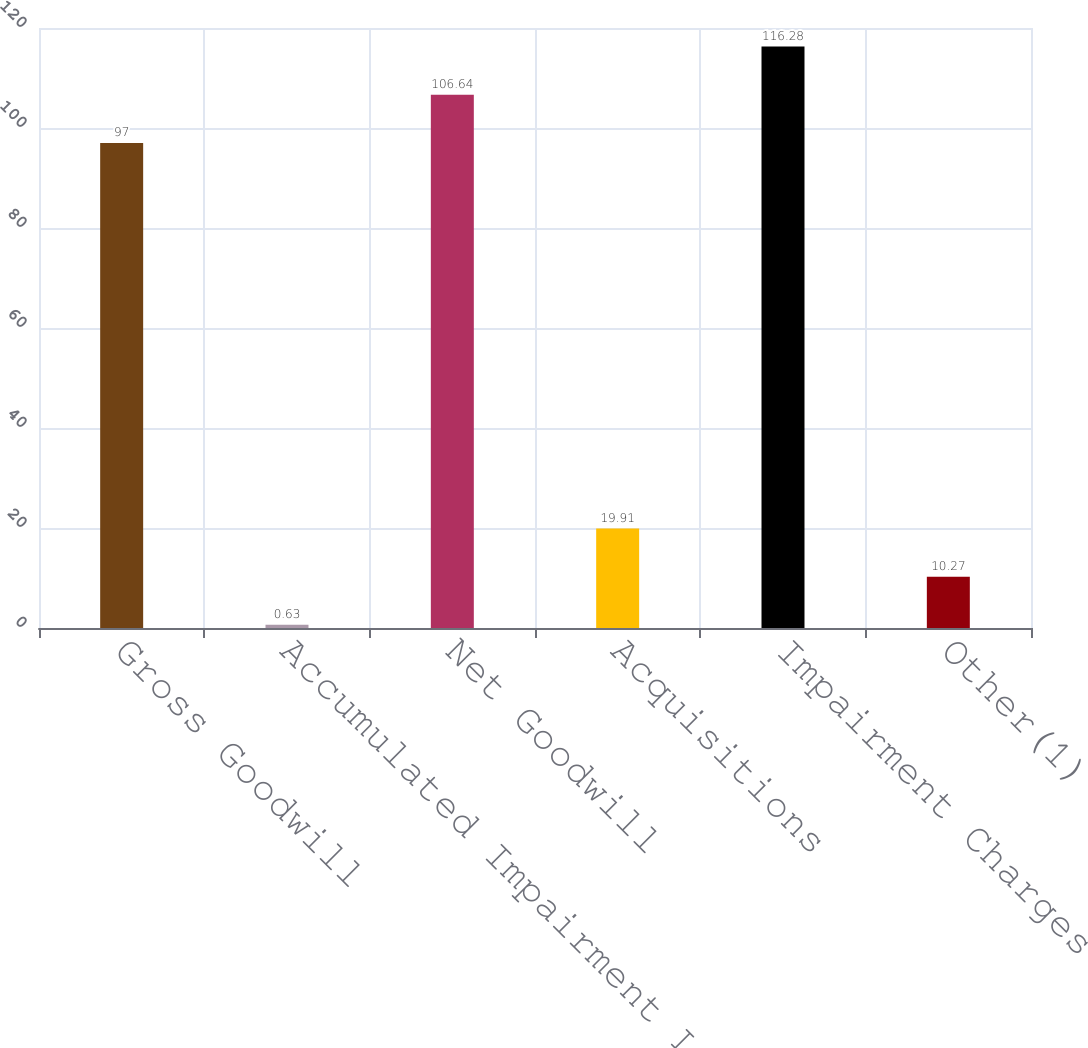Convert chart. <chart><loc_0><loc_0><loc_500><loc_500><bar_chart><fcel>Gross Goodwill<fcel>Accumulated Impairment Losses<fcel>Net Goodwill<fcel>Acquisitions<fcel>Impairment Charges<fcel>Other(1)<nl><fcel>97<fcel>0.63<fcel>106.64<fcel>19.91<fcel>116.28<fcel>10.27<nl></chart> 